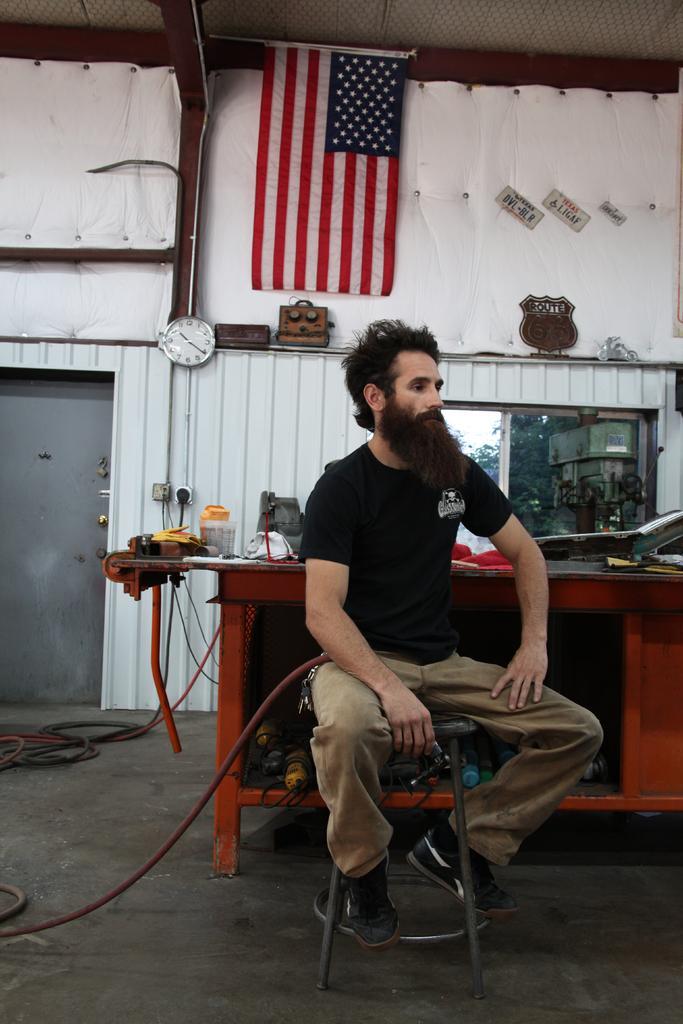Describe this image in one or two sentences. In this image there is one person sitting at bottom of this image is wearing black color t shirt and there is a table at right side of this image and there are some objects kept on it, and there is a wall in the background. There is one flag at top of this image and there is one wall clock at left side of this image and there are some objects are kept on this wall, and there are some are attached with some power supply at left side of this image. There is one door at left side of this image. 